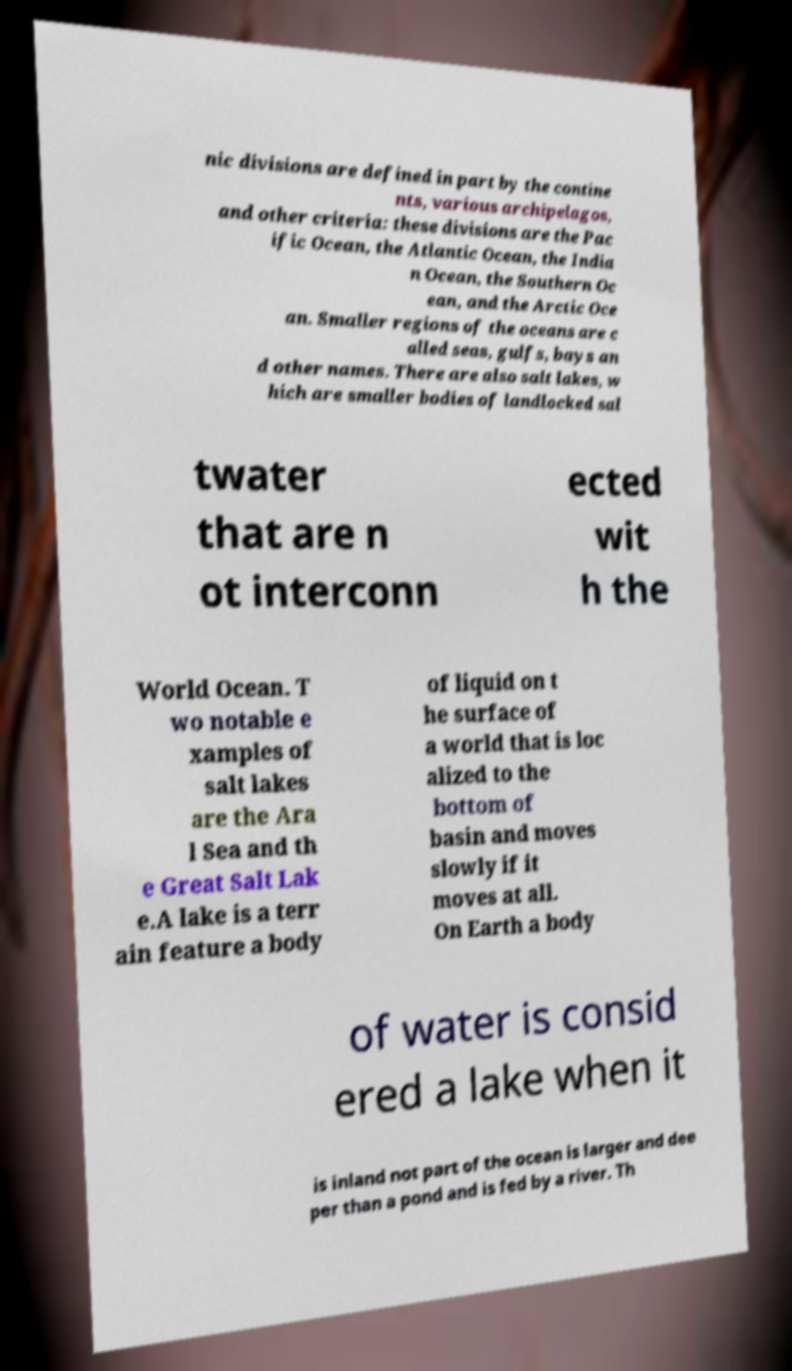What messages or text are displayed in this image? I need them in a readable, typed format. nic divisions are defined in part by the contine nts, various archipelagos, and other criteria: these divisions are the Pac ific Ocean, the Atlantic Ocean, the India n Ocean, the Southern Oc ean, and the Arctic Oce an. Smaller regions of the oceans are c alled seas, gulfs, bays an d other names. There are also salt lakes, w hich are smaller bodies of landlocked sal twater that are n ot interconn ected wit h the World Ocean. T wo notable e xamples of salt lakes are the Ara l Sea and th e Great Salt Lak e.A lake is a terr ain feature a body of liquid on t he surface of a world that is loc alized to the bottom of basin and moves slowly if it moves at all. On Earth a body of water is consid ered a lake when it is inland not part of the ocean is larger and dee per than a pond and is fed by a river. Th 